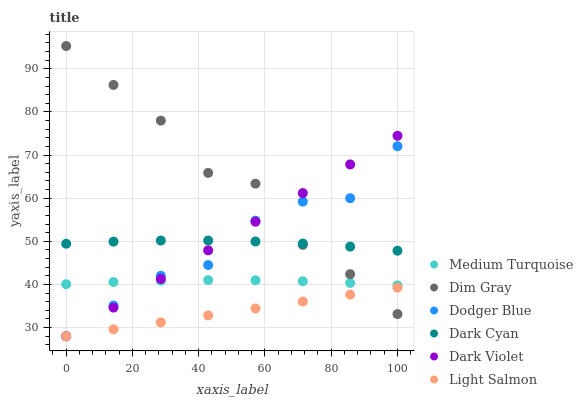Does Light Salmon have the minimum area under the curve?
Answer yes or no. Yes. Does Dim Gray have the maximum area under the curve?
Answer yes or no. Yes. Does Dark Violet have the minimum area under the curve?
Answer yes or no. No. Does Dark Violet have the maximum area under the curve?
Answer yes or no. No. Is Light Salmon the smoothest?
Answer yes or no. Yes. Is Dim Gray the roughest?
Answer yes or no. Yes. Is Dark Violet the smoothest?
Answer yes or no. No. Is Dark Violet the roughest?
Answer yes or no. No. Does Light Salmon have the lowest value?
Answer yes or no. Yes. Does Dim Gray have the lowest value?
Answer yes or no. No. Does Dim Gray have the highest value?
Answer yes or no. Yes. Does Dark Violet have the highest value?
Answer yes or no. No. Is Light Salmon less than Medium Turquoise?
Answer yes or no. Yes. Is Dark Cyan greater than Light Salmon?
Answer yes or no. Yes. Does Light Salmon intersect Dark Violet?
Answer yes or no. Yes. Is Light Salmon less than Dark Violet?
Answer yes or no. No. Is Light Salmon greater than Dark Violet?
Answer yes or no. No. Does Light Salmon intersect Medium Turquoise?
Answer yes or no. No. 